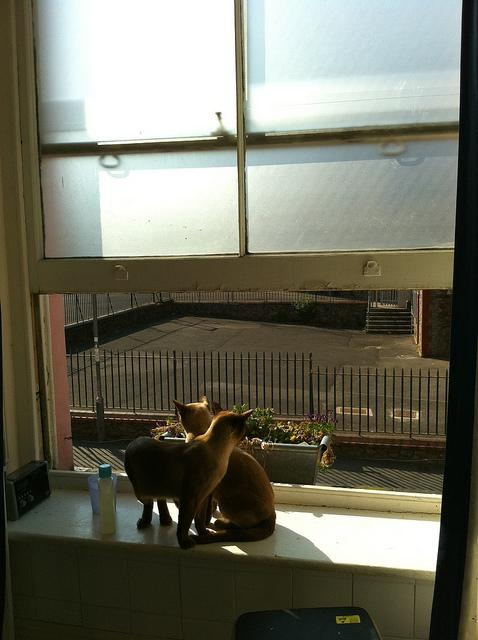How many Siamese cats are sitting atop the window cell?

Choices:
A) one
B) two
C) four
D) three two 